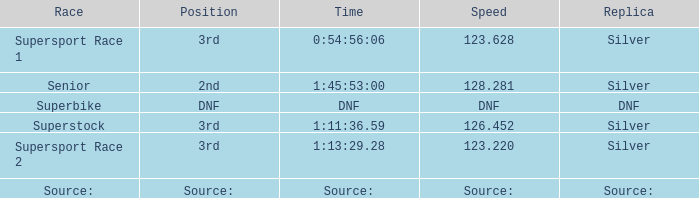Which position has a speed of 123.220? 3rd. 